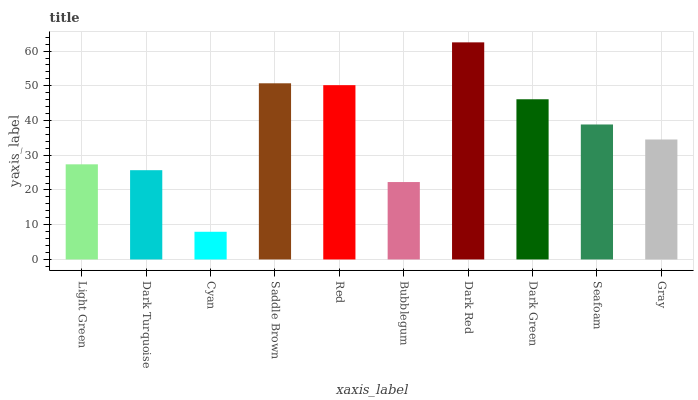Is Cyan the minimum?
Answer yes or no. Yes. Is Dark Red the maximum?
Answer yes or no. Yes. Is Dark Turquoise the minimum?
Answer yes or no. No. Is Dark Turquoise the maximum?
Answer yes or no. No. Is Light Green greater than Dark Turquoise?
Answer yes or no. Yes. Is Dark Turquoise less than Light Green?
Answer yes or no. Yes. Is Dark Turquoise greater than Light Green?
Answer yes or no. No. Is Light Green less than Dark Turquoise?
Answer yes or no. No. Is Seafoam the high median?
Answer yes or no. Yes. Is Gray the low median?
Answer yes or no. Yes. Is Dark Turquoise the high median?
Answer yes or no. No. Is Light Green the low median?
Answer yes or no. No. 